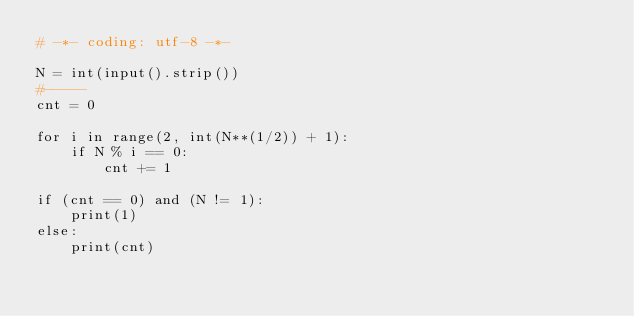<code> <loc_0><loc_0><loc_500><loc_500><_Python_># -*- coding: utf-8 -*-

N = int(input().strip())
#-----
cnt = 0

for i in range(2, int(N**(1/2)) + 1):
    if N % i == 0:
        cnt += 1

if (cnt == 0) and (N != 1):
    print(1)
else:
    print(cnt)
</code> 